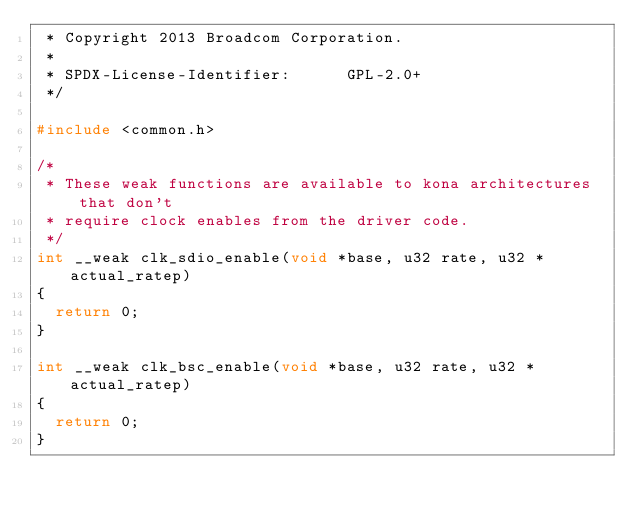<code> <loc_0><loc_0><loc_500><loc_500><_C_> * Copyright 2013 Broadcom Corporation.
 *
 * SPDX-License-Identifier:      GPL-2.0+
 */

#include <common.h>

/*
 * These weak functions are available to kona architectures that don't
 * require clock enables from the driver code.
 */
int __weak clk_sdio_enable(void *base, u32 rate, u32 *actual_ratep)
{
	return 0;
}

int __weak clk_bsc_enable(void *base, u32 rate, u32 *actual_ratep)
{
	return 0;
}
</code> 